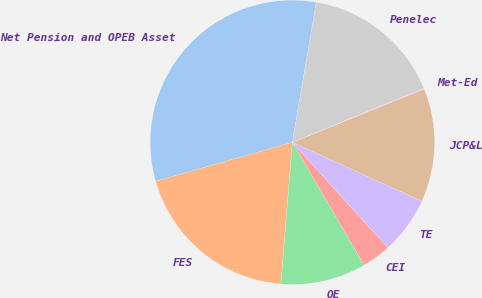Convert chart to OTSL. <chart><loc_0><loc_0><loc_500><loc_500><pie_chart><fcel>Net Pension and OPEB Asset<fcel>FES<fcel>OE<fcel>CEI<fcel>TE<fcel>JCP&L<fcel>Met-Ed<fcel>Penelec<nl><fcel>32.11%<fcel>19.3%<fcel>9.7%<fcel>3.3%<fcel>6.5%<fcel>12.9%<fcel>0.1%<fcel>16.1%<nl></chart> 